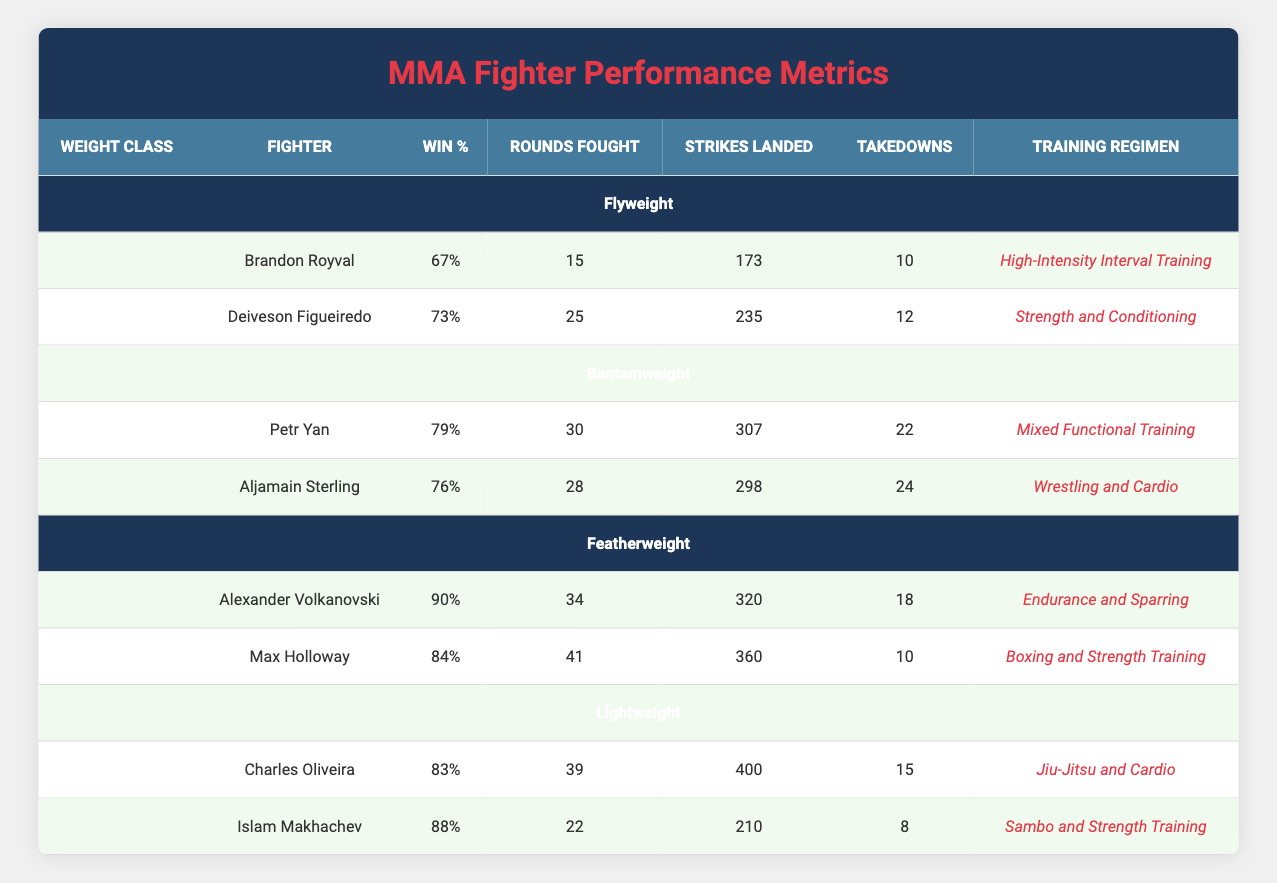What is the win percentage of Alexander Volkanovski? From the table, the win percentage listed for Alexander Volkanovski is 90%.
Answer: 90% Which fighter has the highest number of takedowns in the Bantamweight class? In the Bantamweight section of the table, Petr Yan has 22 takedowns and Aljamain Sterling has 24. Since 24 is greater than 22, Aljamain Sterling has the highest number of takedowns in the Bantamweight class.
Answer: Aljamain Sterling What is the total number of rounds fought by all Lightweights? For the Lightweight class, Charles Oliveira fought 39 rounds and Islam Makhachev fought 22 rounds. Adding these together gives 39 + 22 = 61 rounds fought in total by the Lightweights.
Answer: 61 Is Deiveson Figueiredo's training regimen more focused on strength than Brandon Royval's? Deiveson Figueiredo's training regimen is listed as Strength and Conditioning, while Brandon Royval's is High-Intensity Interval Training. Since Strength and Conditioning is explicitly focused on strength, the statement is true.
Answer: Yes What is the average number of strikes landed by fighters in the Featherweight class? In the Featherweight class, Alexander Volkanovski landed 320 strikes and Max Holloway landed 360 strikes. To find the average, sum these values (320 + 360 = 680) and divide by the number of fighters (680/2 = 340). Therefore, the average is 340 strikes landed by Featherweight fighters.
Answer: 340 Which training regimen shows the lowest win percentage among fighters in the table? The win percentage for High-Intensity Interval Training (Brandon Royval) is 67%, for Strength and Conditioning (Deiveson Figueiredo) is 73%, for Mixed Functional Training (Petr Yan) is 79%, for Wrestling and Cardio (Aljamain Sterling) is 76%, for Endurance and Sparring (Alexander Volkanovski) is 90%, for Boxing and Strength Training (Max Holloway) is 84%, for Jiu-Jitsu and Cardio (Charles Oliveira) is 83%, and for Sambo and Strength Training (Islam Makhachev) is 88%. The lowest win percentage is 67% for Brandon Royval.
Answer: 67% How does the total number of takedowns by fighters in Lightweight compare to those in Flyweight? In the Lightweight class, Charles Oliveira has 15 takedowns and Islam Makhachev has 8, making a total of 15 + 8 = 23 takedowns. In the Flyweight class, Brandon Royval has 10 takedowns and Deiveson Figueiredo has 12, making a total of 10 + 12 = 22 takedowns. The Lightweight class has 23 takedowns and Flyweight has 22, showing that Lightweights have 1 more takedown than Flyweights.
Answer: Lightweights have more takedowns What fighter has the fewest rounds fought? Looking at the table, Brandon Royval has 15 rounds fought, Deiveson Figueiredo has 25, Petr Yan has 30, Aljamain Sterling has 28, Alexander Volkanovski has 34, Max Holloway has 41, Charles Oliveira has 39, and Islam Makhachev has 22 rounds fought. Thus, Brandon Royval has the fewest rounds fought.
Answer: Brandon Royval 